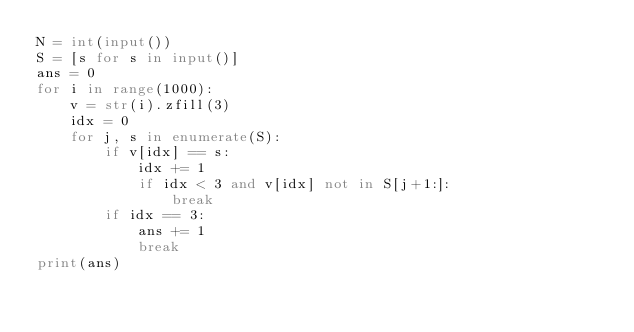Convert code to text. <code><loc_0><loc_0><loc_500><loc_500><_Python_>N = int(input())
S = [s for s in input()]
ans = 0
for i in range(1000):
    v = str(i).zfill(3)
    idx = 0
    for j, s in enumerate(S):
        if v[idx] == s:
            idx += 1
            if idx < 3 and v[idx] not in S[j+1:]:
                break
        if idx == 3:
            ans += 1
            break
print(ans)</code> 